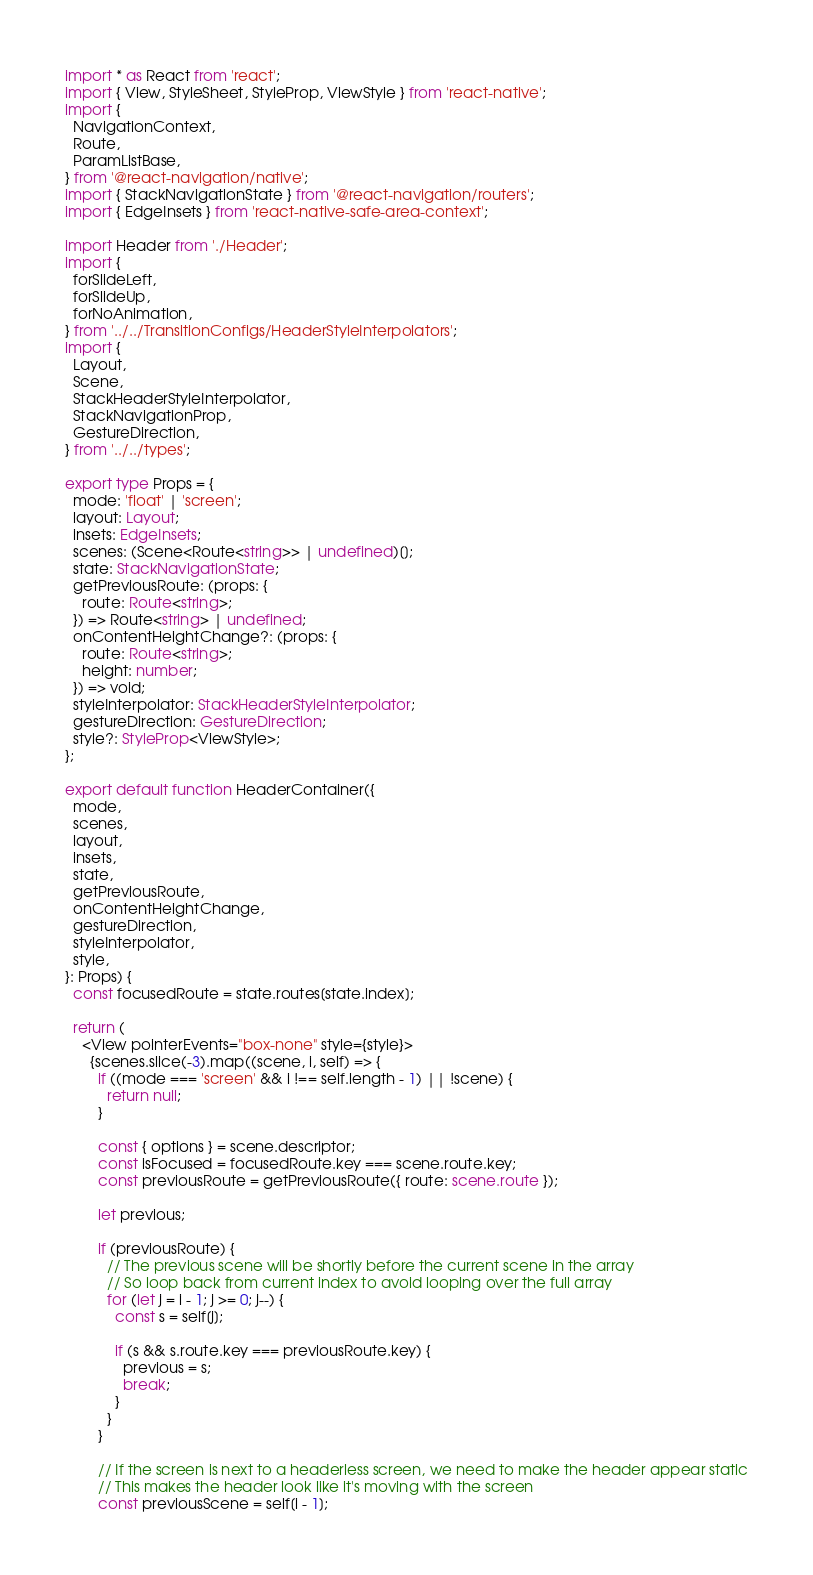<code> <loc_0><loc_0><loc_500><loc_500><_TypeScript_>import * as React from 'react';
import { View, StyleSheet, StyleProp, ViewStyle } from 'react-native';
import {
  NavigationContext,
  Route,
  ParamListBase,
} from '@react-navigation/native';
import { StackNavigationState } from '@react-navigation/routers';
import { EdgeInsets } from 'react-native-safe-area-context';

import Header from './Header';
import {
  forSlideLeft,
  forSlideUp,
  forNoAnimation,
} from '../../TransitionConfigs/HeaderStyleInterpolators';
import {
  Layout,
  Scene,
  StackHeaderStyleInterpolator,
  StackNavigationProp,
  GestureDirection,
} from '../../types';

export type Props = {
  mode: 'float' | 'screen';
  layout: Layout;
  insets: EdgeInsets;
  scenes: (Scene<Route<string>> | undefined)[];
  state: StackNavigationState;
  getPreviousRoute: (props: {
    route: Route<string>;
  }) => Route<string> | undefined;
  onContentHeightChange?: (props: {
    route: Route<string>;
    height: number;
  }) => void;
  styleInterpolator: StackHeaderStyleInterpolator;
  gestureDirection: GestureDirection;
  style?: StyleProp<ViewStyle>;
};

export default function HeaderContainer({
  mode,
  scenes,
  layout,
  insets,
  state,
  getPreviousRoute,
  onContentHeightChange,
  gestureDirection,
  styleInterpolator,
  style,
}: Props) {
  const focusedRoute = state.routes[state.index];

  return (
    <View pointerEvents="box-none" style={style}>
      {scenes.slice(-3).map((scene, i, self) => {
        if ((mode === 'screen' && i !== self.length - 1) || !scene) {
          return null;
        }

        const { options } = scene.descriptor;
        const isFocused = focusedRoute.key === scene.route.key;
        const previousRoute = getPreviousRoute({ route: scene.route });

        let previous;

        if (previousRoute) {
          // The previous scene will be shortly before the current scene in the array
          // So loop back from current index to avoid looping over the full array
          for (let j = i - 1; j >= 0; j--) {
            const s = self[j];

            if (s && s.route.key === previousRoute.key) {
              previous = s;
              break;
            }
          }
        }

        // If the screen is next to a headerless screen, we need to make the header appear static
        // This makes the header look like it's moving with the screen
        const previousScene = self[i - 1];</code> 